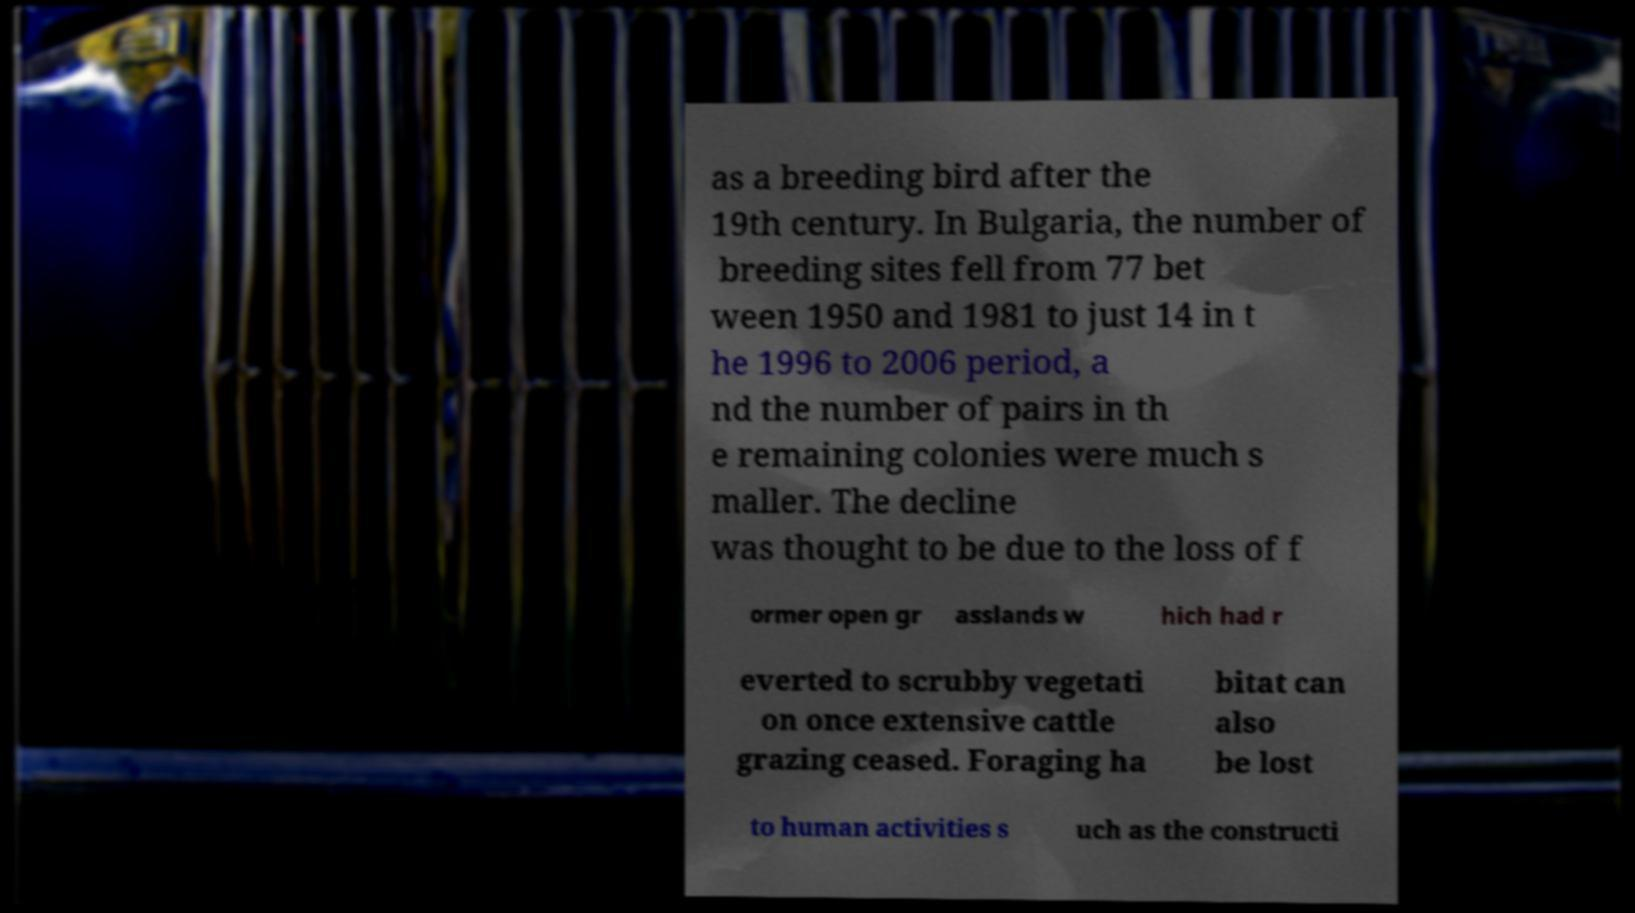There's text embedded in this image that I need extracted. Can you transcribe it verbatim? as a breeding bird after the 19th century. In Bulgaria, the number of breeding sites fell from 77 bet ween 1950 and 1981 to just 14 in t he 1996 to 2006 period, a nd the number of pairs in th e remaining colonies were much s maller. The decline was thought to be due to the loss of f ormer open gr asslands w hich had r everted to scrubby vegetati on once extensive cattle grazing ceased. Foraging ha bitat can also be lost to human activities s uch as the constructi 